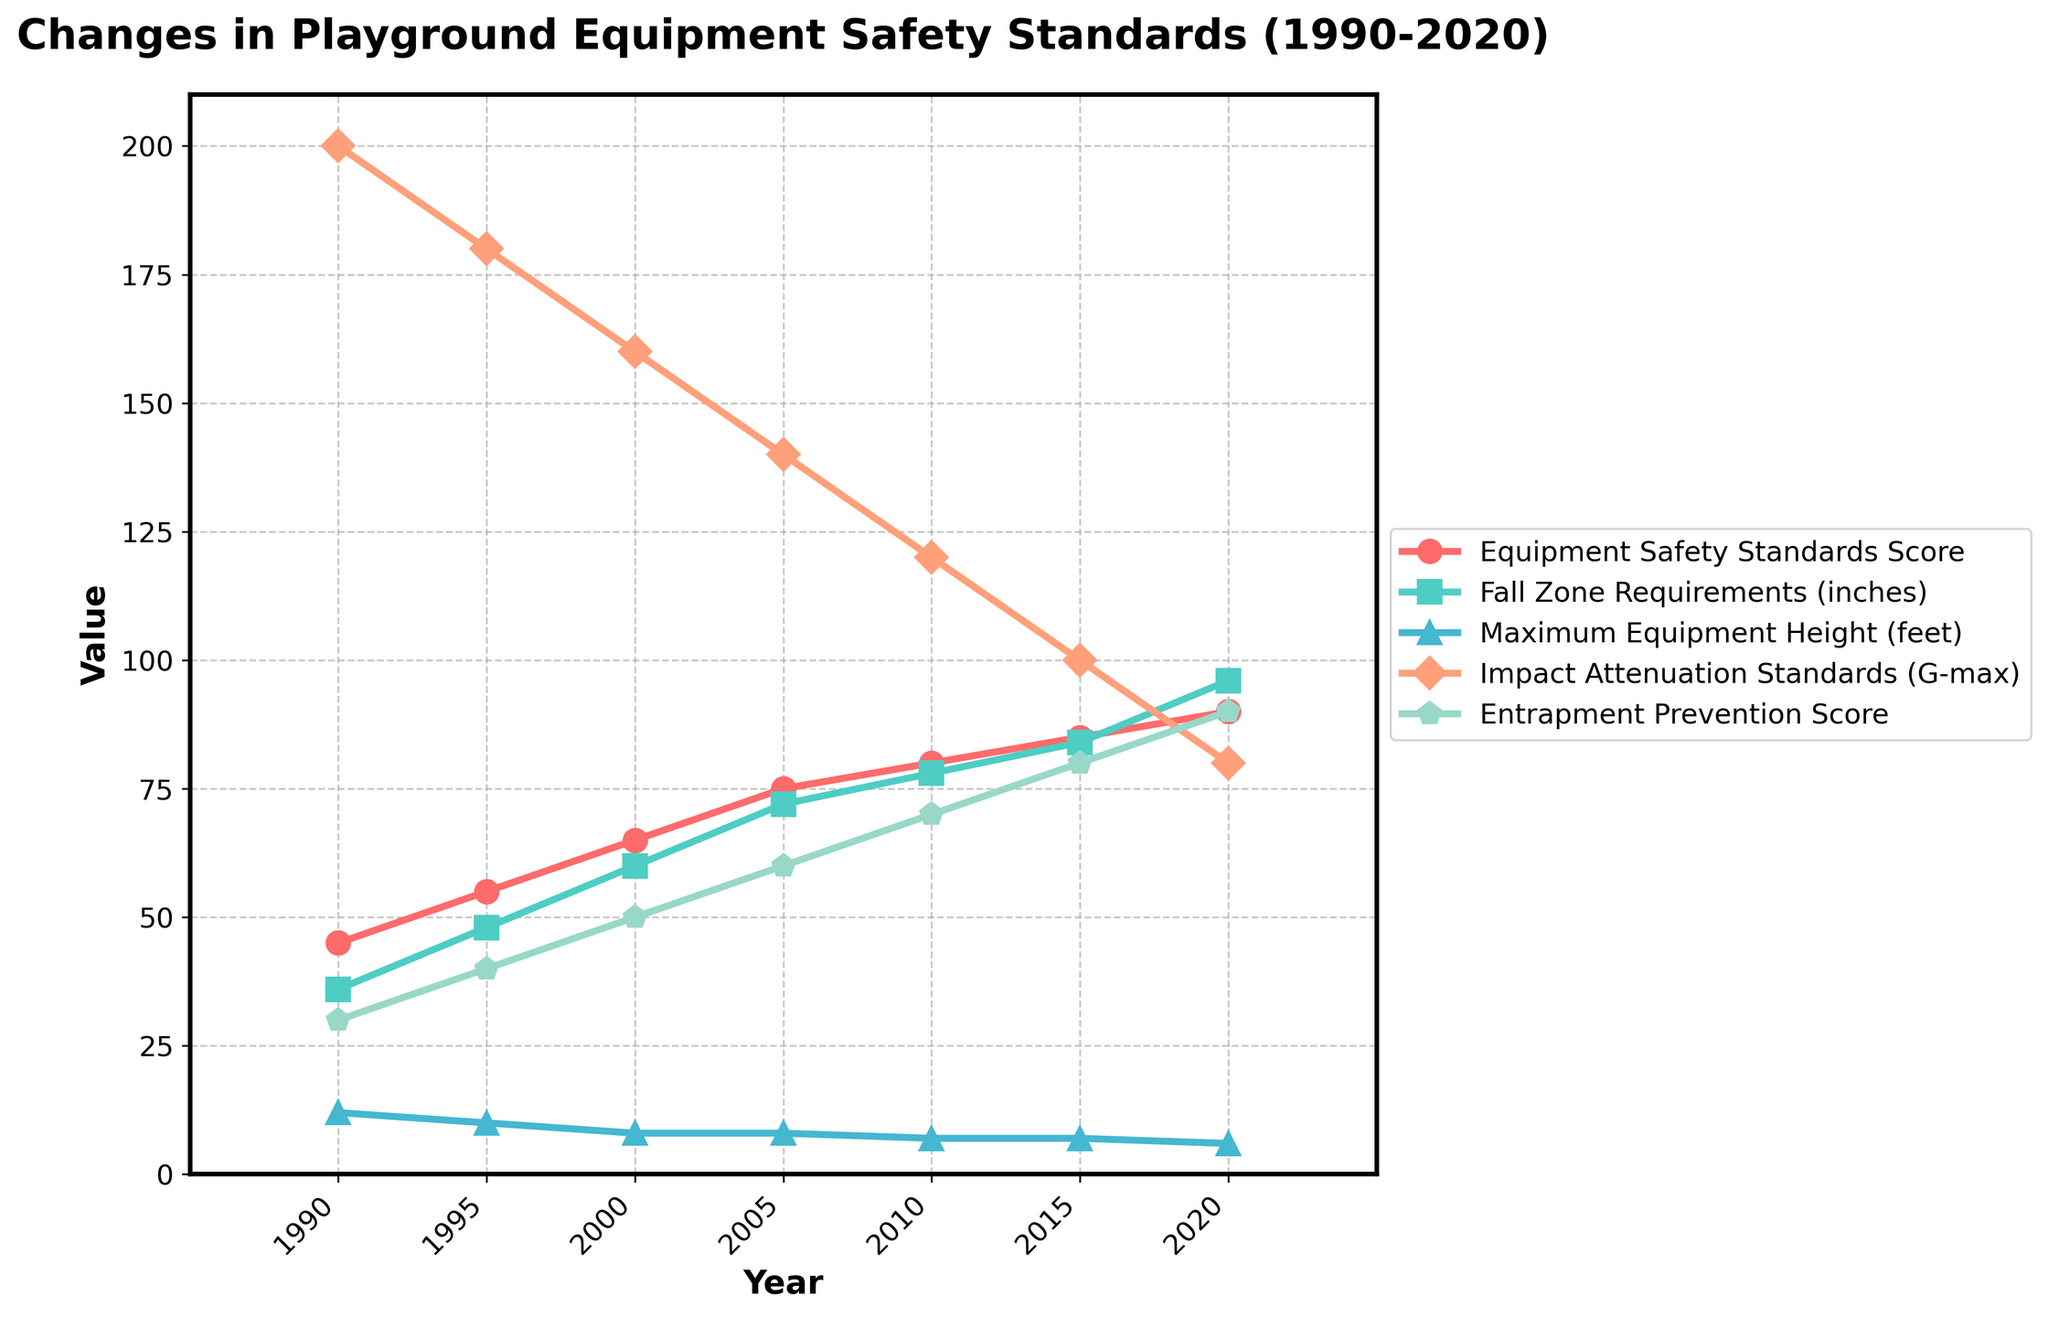What is the trend in the Equipment Safety Standards Score over the years? Look at the line representing the Equipment Safety Standards Score. It starts at 45 in 1990 and steadily increases, reaching 90 in 2020. This indicates a positive trend.
Answer: Increasing What is the difference in Maximum Equipment Height between 2000 and 2020? The Maximum Equipment Height in 2000 is 8 feet and in 2020 it is 6 feet. The difference is 8 - 6 = 2 feet.
Answer: 2 feet What year had the highest Impact Attenuation Standards (G-max)? Look at the line representing Impact Attenuation Standards (G-max). The highest value is 200 in 1990. This means the highest standard was in 1990.
Answer: 1990 By how many inches did Fall Zone Requirements increase from 1995 to 2020? Fall Zone Requirements in 1995 are 48 inches and in 2020 they are 96 inches. The increase is 96 - 48 = 48 inches.
Answer: 48 inches What is the average Entrapment Prevention Score from 2000 to 2020? The Entrapment Prevention Scores from the years 2000, 2005, 2010, 2015, and 2020 are 50, 60, 70, 80, and 90 respectively. The average is (50 + 60 + 70 + 80 + 90) / 5 = 70.
Answer: 70 Which metric saw the greatest improvement from 1990 to 2020? Look at the lines for all metrics from 1990 to 2020. The Equipment Safety Standards Score increased the most, from 45 to 90, an increase of 45.
Answer: Equipment Safety Standards Score How did the Fall Zone Requirements change between 1995 and 2005? The Fall Zone Requirements in 1995 were 48 inches and in 2005 they were 72 inches. They increased by 72 - 48 = 24 inches.
Answer: Increased by 24 inches Compare the Entrapment Prevention Score and Equipment Safety Standards Score in 2015. Which one is higher? In 2015, the Entrapment Prevention Score is 80 and the Equipment Safety Standards Score is 85. Therefore, the Equipment Safety Standards Score is higher.
Answer: Equipment Safety Standards Score What is the percentage decrease in Impact Attenuation Standards (G-max) from 1990 to 2020? Impact Attenuation Standards (G-max) were 200 in 1990 and 80 in 2020. The decrease is 200 - 80 = 120. The percentage decrease is (120/200) * 100 = 60%.
Answer: 60% During which decade did the Maximum Equipment Height see the most significant reduction? Look at the Maximum Equipment Height line. The most significant reduction happened between 2000 (8 feet) and 2020 (6 feet).
Answer: 2000s to 2010s 